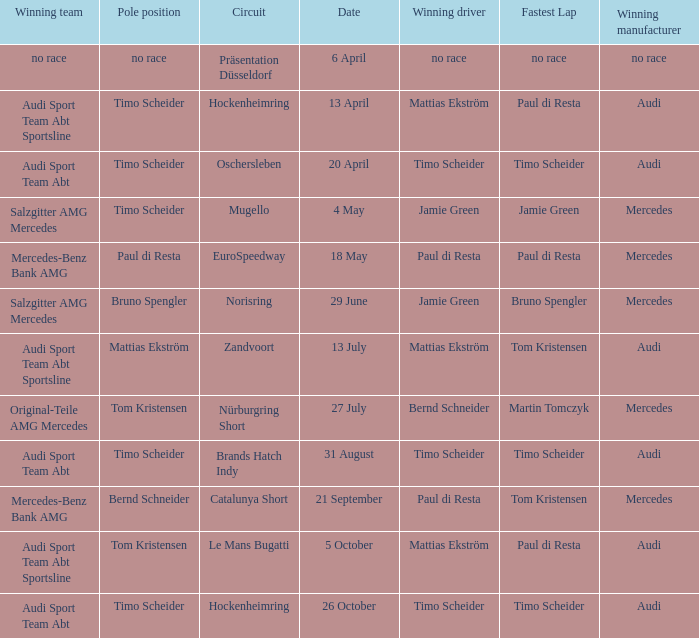What is the fastest lap of the Oschersleben circuit with Audi Sport Team ABT as the winning team? Timo Scheider. 